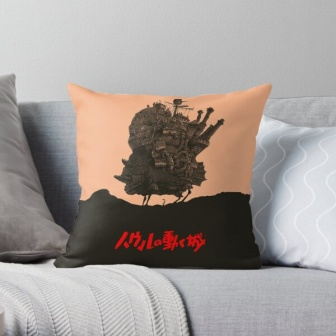Create a poem inspired by the elements in this image. Upon the couch of gray and calm,
A pillow rests, a charming psalm,
In peach and black, a tale is spun,
Of castles high where dreams are won.

Flags wave atop the towers tall,
In shadows deep, through twilight’s call,
'Miyazaki' whispers stories old,
Of lands afar and treasures bold.

The blanket’s weave, in patterns bright,
Softly cradles curtains of night,
Where magic weaves and courage stands,
In cozy realms of pillow lands. 